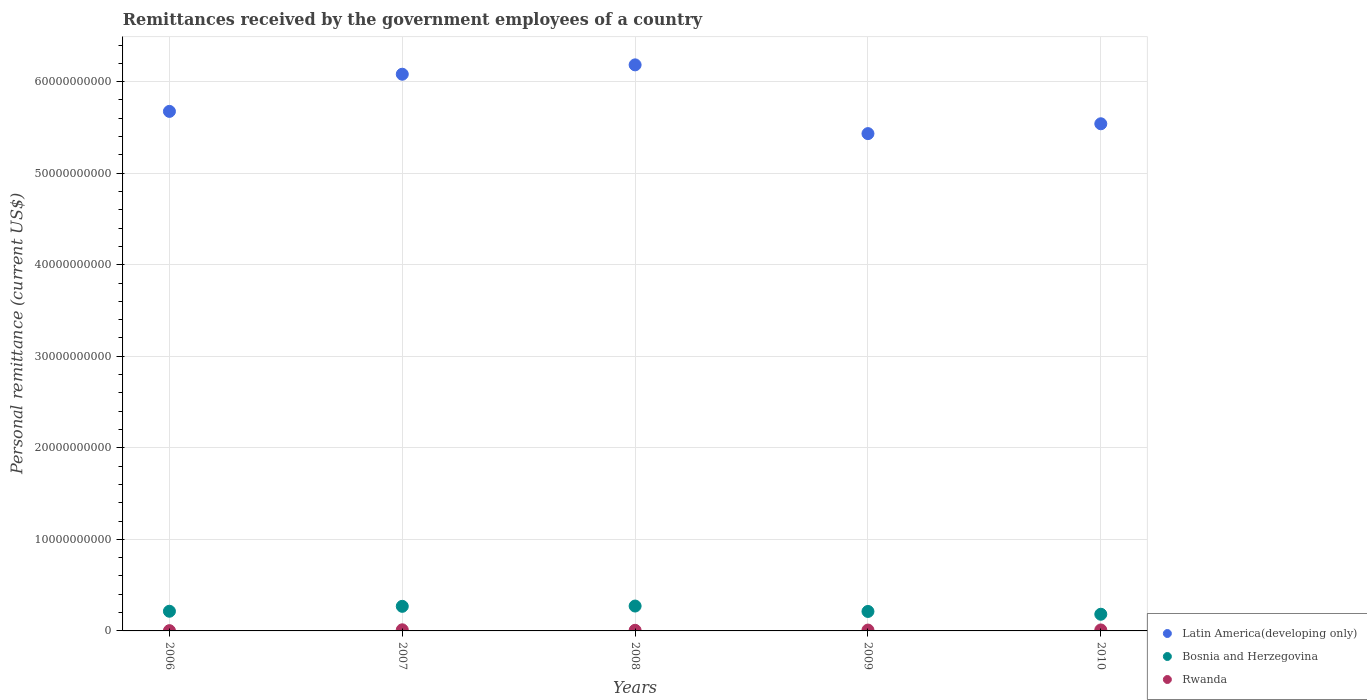How many different coloured dotlines are there?
Provide a succinct answer. 3. Is the number of dotlines equal to the number of legend labels?
Offer a terse response. Yes. What is the remittances received by the government employees in Rwanda in 2006?
Your response must be concise. 2.90e+07. Across all years, what is the maximum remittances received by the government employees in Latin America(developing only)?
Give a very brief answer. 6.18e+1. Across all years, what is the minimum remittances received by the government employees in Latin America(developing only)?
Make the answer very short. 5.43e+1. In which year was the remittances received by the government employees in Bosnia and Herzegovina maximum?
Provide a short and direct response. 2008. In which year was the remittances received by the government employees in Rwanda minimum?
Your answer should be compact. 2006. What is the total remittances received by the government employees in Bosnia and Herzegovina in the graph?
Provide a short and direct response. 1.15e+1. What is the difference between the remittances received by the government employees in Bosnia and Herzegovina in 2006 and that in 2007?
Your response must be concise. -5.37e+08. What is the difference between the remittances received by the government employees in Rwanda in 2006 and the remittances received by the government employees in Bosnia and Herzegovina in 2008?
Your answer should be very brief. -2.69e+09. What is the average remittances received by the government employees in Latin America(developing only) per year?
Make the answer very short. 5.78e+1. In the year 2010, what is the difference between the remittances received by the government employees in Latin America(developing only) and remittances received by the government employees in Bosnia and Herzegovina?
Offer a terse response. 5.36e+1. In how many years, is the remittances received by the government employees in Bosnia and Herzegovina greater than 36000000000 US$?
Your answer should be very brief. 0. What is the ratio of the remittances received by the government employees in Bosnia and Herzegovina in 2008 to that in 2009?
Your answer should be compact. 1.28. Is the difference between the remittances received by the government employees in Latin America(developing only) in 2009 and 2010 greater than the difference between the remittances received by the government employees in Bosnia and Herzegovina in 2009 and 2010?
Provide a succinct answer. No. What is the difference between the highest and the second highest remittances received by the government employees in Rwanda?
Make the answer very short. 1.50e+07. What is the difference between the highest and the lowest remittances received by the government employees in Rwanda?
Ensure brevity in your answer.  9.25e+07. Is the sum of the remittances received by the government employees in Latin America(developing only) in 2006 and 2007 greater than the maximum remittances received by the government employees in Rwanda across all years?
Provide a short and direct response. Yes. Does the remittances received by the government employees in Latin America(developing only) monotonically increase over the years?
Provide a short and direct response. No. Is the remittances received by the government employees in Bosnia and Herzegovina strictly less than the remittances received by the government employees in Rwanda over the years?
Your response must be concise. No. How many dotlines are there?
Provide a short and direct response. 3. What is the difference between two consecutive major ticks on the Y-axis?
Your answer should be compact. 1.00e+1. How are the legend labels stacked?
Offer a terse response. Vertical. What is the title of the graph?
Your answer should be very brief. Remittances received by the government employees of a country. What is the label or title of the X-axis?
Your response must be concise. Years. What is the label or title of the Y-axis?
Ensure brevity in your answer.  Personal remittance (current US$). What is the Personal remittance (current US$) of Latin America(developing only) in 2006?
Offer a very short reply. 5.68e+1. What is the Personal remittance (current US$) in Bosnia and Herzegovina in 2006?
Provide a succinct answer. 2.15e+09. What is the Personal remittance (current US$) in Rwanda in 2006?
Your answer should be compact. 2.90e+07. What is the Personal remittance (current US$) of Latin America(developing only) in 2007?
Your answer should be very brief. 6.08e+1. What is the Personal remittance (current US$) in Bosnia and Herzegovina in 2007?
Ensure brevity in your answer.  2.69e+09. What is the Personal remittance (current US$) of Rwanda in 2007?
Your answer should be very brief. 1.21e+08. What is the Personal remittance (current US$) of Latin America(developing only) in 2008?
Provide a short and direct response. 6.18e+1. What is the Personal remittance (current US$) of Bosnia and Herzegovina in 2008?
Provide a succinct answer. 2.72e+09. What is the Personal remittance (current US$) in Rwanda in 2008?
Provide a short and direct response. 6.78e+07. What is the Personal remittance (current US$) of Latin America(developing only) in 2009?
Keep it short and to the point. 5.43e+1. What is the Personal remittance (current US$) of Bosnia and Herzegovina in 2009?
Ensure brevity in your answer.  2.13e+09. What is the Personal remittance (current US$) of Rwanda in 2009?
Offer a very short reply. 9.26e+07. What is the Personal remittance (current US$) in Latin America(developing only) in 2010?
Your answer should be very brief. 5.54e+1. What is the Personal remittance (current US$) of Bosnia and Herzegovina in 2010?
Provide a short and direct response. 1.82e+09. What is the Personal remittance (current US$) in Rwanda in 2010?
Ensure brevity in your answer.  1.06e+08. Across all years, what is the maximum Personal remittance (current US$) in Latin America(developing only)?
Make the answer very short. 6.18e+1. Across all years, what is the maximum Personal remittance (current US$) in Bosnia and Herzegovina?
Offer a very short reply. 2.72e+09. Across all years, what is the maximum Personal remittance (current US$) in Rwanda?
Keep it short and to the point. 1.21e+08. Across all years, what is the minimum Personal remittance (current US$) in Latin America(developing only)?
Keep it short and to the point. 5.43e+1. Across all years, what is the minimum Personal remittance (current US$) in Bosnia and Herzegovina?
Ensure brevity in your answer.  1.82e+09. Across all years, what is the minimum Personal remittance (current US$) of Rwanda?
Give a very brief answer. 2.90e+07. What is the total Personal remittance (current US$) of Latin America(developing only) in the graph?
Ensure brevity in your answer.  2.89e+11. What is the total Personal remittance (current US$) in Bosnia and Herzegovina in the graph?
Your answer should be compact. 1.15e+1. What is the total Personal remittance (current US$) of Rwanda in the graph?
Provide a short and direct response. 4.17e+08. What is the difference between the Personal remittance (current US$) in Latin America(developing only) in 2006 and that in 2007?
Ensure brevity in your answer.  -4.06e+09. What is the difference between the Personal remittance (current US$) of Bosnia and Herzegovina in 2006 and that in 2007?
Your response must be concise. -5.37e+08. What is the difference between the Personal remittance (current US$) in Rwanda in 2006 and that in 2007?
Provide a succinct answer. -9.25e+07. What is the difference between the Personal remittance (current US$) of Latin America(developing only) in 2006 and that in 2008?
Your answer should be compact. -5.08e+09. What is the difference between the Personal remittance (current US$) in Bosnia and Herzegovina in 2006 and that in 2008?
Ensure brevity in your answer.  -5.69e+08. What is the difference between the Personal remittance (current US$) of Rwanda in 2006 and that in 2008?
Your answer should be compact. -3.88e+07. What is the difference between the Personal remittance (current US$) in Latin America(developing only) in 2006 and that in 2009?
Ensure brevity in your answer.  2.43e+09. What is the difference between the Personal remittance (current US$) in Bosnia and Herzegovina in 2006 and that in 2009?
Offer a terse response. 2.19e+07. What is the difference between the Personal remittance (current US$) of Rwanda in 2006 and that in 2009?
Offer a terse response. -6.36e+07. What is the difference between the Personal remittance (current US$) in Latin America(developing only) in 2006 and that in 2010?
Provide a short and direct response. 1.35e+09. What is the difference between the Personal remittance (current US$) of Bosnia and Herzegovina in 2006 and that in 2010?
Provide a short and direct response. 3.27e+08. What is the difference between the Personal remittance (current US$) in Rwanda in 2006 and that in 2010?
Ensure brevity in your answer.  -7.75e+07. What is the difference between the Personal remittance (current US$) of Latin America(developing only) in 2007 and that in 2008?
Your answer should be compact. -1.02e+09. What is the difference between the Personal remittance (current US$) in Bosnia and Herzegovina in 2007 and that in 2008?
Offer a terse response. -3.12e+07. What is the difference between the Personal remittance (current US$) in Rwanda in 2007 and that in 2008?
Your answer should be very brief. 5.37e+07. What is the difference between the Personal remittance (current US$) in Latin America(developing only) in 2007 and that in 2009?
Keep it short and to the point. 6.49e+09. What is the difference between the Personal remittance (current US$) of Bosnia and Herzegovina in 2007 and that in 2009?
Provide a short and direct response. 5.59e+08. What is the difference between the Personal remittance (current US$) of Rwanda in 2007 and that in 2009?
Offer a terse response. 2.89e+07. What is the difference between the Personal remittance (current US$) in Latin America(developing only) in 2007 and that in 2010?
Keep it short and to the point. 5.41e+09. What is the difference between the Personal remittance (current US$) of Bosnia and Herzegovina in 2007 and that in 2010?
Your answer should be very brief. 8.64e+08. What is the difference between the Personal remittance (current US$) of Rwanda in 2007 and that in 2010?
Offer a terse response. 1.50e+07. What is the difference between the Personal remittance (current US$) of Latin America(developing only) in 2008 and that in 2009?
Keep it short and to the point. 7.51e+09. What is the difference between the Personal remittance (current US$) in Bosnia and Herzegovina in 2008 and that in 2009?
Provide a succinct answer. 5.91e+08. What is the difference between the Personal remittance (current US$) in Rwanda in 2008 and that in 2009?
Your answer should be compact. -2.48e+07. What is the difference between the Personal remittance (current US$) in Latin America(developing only) in 2008 and that in 2010?
Offer a terse response. 6.44e+09. What is the difference between the Personal remittance (current US$) in Bosnia and Herzegovina in 2008 and that in 2010?
Your answer should be compact. 8.95e+08. What is the difference between the Personal remittance (current US$) of Rwanda in 2008 and that in 2010?
Offer a very short reply. -3.87e+07. What is the difference between the Personal remittance (current US$) of Latin America(developing only) in 2009 and that in 2010?
Provide a short and direct response. -1.07e+09. What is the difference between the Personal remittance (current US$) in Bosnia and Herzegovina in 2009 and that in 2010?
Keep it short and to the point. 3.05e+08. What is the difference between the Personal remittance (current US$) in Rwanda in 2009 and that in 2010?
Offer a terse response. -1.38e+07. What is the difference between the Personal remittance (current US$) in Latin America(developing only) in 2006 and the Personal remittance (current US$) in Bosnia and Herzegovina in 2007?
Give a very brief answer. 5.41e+1. What is the difference between the Personal remittance (current US$) in Latin America(developing only) in 2006 and the Personal remittance (current US$) in Rwanda in 2007?
Your answer should be compact. 5.66e+1. What is the difference between the Personal remittance (current US$) of Bosnia and Herzegovina in 2006 and the Personal remittance (current US$) of Rwanda in 2007?
Offer a very short reply. 2.03e+09. What is the difference between the Personal remittance (current US$) of Latin America(developing only) in 2006 and the Personal remittance (current US$) of Bosnia and Herzegovina in 2008?
Your answer should be very brief. 5.40e+1. What is the difference between the Personal remittance (current US$) of Latin America(developing only) in 2006 and the Personal remittance (current US$) of Rwanda in 2008?
Provide a short and direct response. 5.67e+1. What is the difference between the Personal remittance (current US$) in Bosnia and Herzegovina in 2006 and the Personal remittance (current US$) in Rwanda in 2008?
Your answer should be compact. 2.08e+09. What is the difference between the Personal remittance (current US$) of Latin America(developing only) in 2006 and the Personal remittance (current US$) of Bosnia and Herzegovina in 2009?
Your answer should be compact. 5.46e+1. What is the difference between the Personal remittance (current US$) in Latin America(developing only) in 2006 and the Personal remittance (current US$) in Rwanda in 2009?
Make the answer very short. 5.67e+1. What is the difference between the Personal remittance (current US$) of Bosnia and Herzegovina in 2006 and the Personal remittance (current US$) of Rwanda in 2009?
Keep it short and to the point. 2.06e+09. What is the difference between the Personal remittance (current US$) in Latin America(developing only) in 2006 and the Personal remittance (current US$) in Bosnia and Herzegovina in 2010?
Ensure brevity in your answer.  5.49e+1. What is the difference between the Personal remittance (current US$) of Latin America(developing only) in 2006 and the Personal remittance (current US$) of Rwanda in 2010?
Your answer should be very brief. 5.66e+1. What is the difference between the Personal remittance (current US$) of Bosnia and Herzegovina in 2006 and the Personal remittance (current US$) of Rwanda in 2010?
Provide a short and direct response. 2.04e+09. What is the difference between the Personal remittance (current US$) of Latin America(developing only) in 2007 and the Personal remittance (current US$) of Bosnia and Herzegovina in 2008?
Keep it short and to the point. 5.81e+1. What is the difference between the Personal remittance (current US$) in Latin America(developing only) in 2007 and the Personal remittance (current US$) in Rwanda in 2008?
Your answer should be compact. 6.07e+1. What is the difference between the Personal remittance (current US$) of Bosnia and Herzegovina in 2007 and the Personal remittance (current US$) of Rwanda in 2008?
Offer a terse response. 2.62e+09. What is the difference between the Personal remittance (current US$) of Latin America(developing only) in 2007 and the Personal remittance (current US$) of Bosnia and Herzegovina in 2009?
Give a very brief answer. 5.87e+1. What is the difference between the Personal remittance (current US$) in Latin America(developing only) in 2007 and the Personal remittance (current US$) in Rwanda in 2009?
Your answer should be very brief. 6.07e+1. What is the difference between the Personal remittance (current US$) in Bosnia and Herzegovina in 2007 and the Personal remittance (current US$) in Rwanda in 2009?
Give a very brief answer. 2.59e+09. What is the difference between the Personal remittance (current US$) of Latin America(developing only) in 2007 and the Personal remittance (current US$) of Bosnia and Herzegovina in 2010?
Offer a very short reply. 5.90e+1. What is the difference between the Personal remittance (current US$) in Latin America(developing only) in 2007 and the Personal remittance (current US$) in Rwanda in 2010?
Provide a succinct answer. 6.07e+1. What is the difference between the Personal remittance (current US$) of Bosnia and Herzegovina in 2007 and the Personal remittance (current US$) of Rwanda in 2010?
Provide a succinct answer. 2.58e+09. What is the difference between the Personal remittance (current US$) in Latin America(developing only) in 2008 and the Personal remittance (current US$) in Bosnia and Herzegovina in 2009?
Offer a terse response. 5.97e+1. What is the difference between the Personal remittance (current US$) in Latin America(developing only) in 2008 and the Personal remittance (current US$) in Rwanda in 2009?
Offer a terse response. 6.17e+1. What is the difference between the Personal remittance (current US$) of Bosnia and Herzegovina in 2008 and the Personal remittance (current US$) of Rwanda in 2009?
Give a very brief answer. 2.63e+09. What is the difference between the Personal remittance (current US$) in Latin America(developing only) in 2008 and the Personal remittance (current US$) in Bosnia and Herzegovina in 2010?
Offer a terse response. 6.00e+1. What is the difference between the Personal remittance (current US$) in Latin America(developing only) in 2008 and the Personal remittance (current US$) in Rwanda in 2010?
Provide a succinct answer. 6.17e+1. What is the difference between the Personal remittance (current US$) of Bosnia and Herzegovina in 2008 and the Personal remittance (current US$) of Rwanda in 2010?
Provide a short and direct response. 2.61e+09. What is the difference between the Personal remittance (current US$) of Latin America(developing only) in 2009 and the Personal remittance (current US$) of Bosnia and Herzegovina in 2010?
Your answer should be very brief. 5.25e+1. What is the difference between the Personal remittance (current US$) in Latin America(developing only) in 2009 and the Personal remittance (current US$) in Rwanda in 2010?
Your response must be concise. 5.42e+1. What is the difference between the Personal remittance (current US$) in Bosnia and Herzegovina in 2009 and the Personal remittance (current US$) in Rwanda in 2010?
Make the answer very short. 2.02e+09. What is the average Personal remittance (current US$) in Latin America(developing only) per year?
Provide a succinct answer. 5.78e+1. What is the average Personal remittance (current US$) of Bosnia and Herzegovina per year?
Offer a very short reply. 2.30e+09. What is the average Personal remittance (current US$) of Rwanda per year?
Ensure brevity in your answer.  8.35e+07. In the year 2006, what is the difference between the Personal remittance (current US$) of Latin America(developing only) and Personal remittance (current US$) of Bosnia and Herzegovina?
Your response must be concise. 5.46e+1. In the year 2006, what is the difference between the Personal remittance (current US$) of Latin America(developing only) and Personal remittance (current US$) of Rwanda?
Provide a short and direct response. 5.67e+1. In the year 2006, what is the difference between the Personal remittance (current US$) in Bosnia and Herzegovina and Personal remittance (current US$) in Rwanda?
Provide a short and direct response. 2.12e+09. In the year 2007, what is the difference between the Personal remittance (current US$) in Latin America(developing only) and Personal remittance (current US$) in Bosnia and Herzegovina?
Ensure brevity in your answer.  5.81e+1. In the year 2007, what is the difference between the Personal remittance (current US$) of Latin America(developing only) and Personal remittance (current US$) of Rwanda?
Give a very brief answer. 6.07e+1. In the year 2007, what is the difference between the Personal remittance (current US$) of Bosnia and Herzegovina and Personal remittance (current US$) of Rwanda?
Make the answer very short. 2.56e+09. In the year 2008, what is the difference between the Personal remittance (current US$) of Latin America(developing only) and Personal remittance (current US$) of Bosnia and Herzegovina?
Ensure brevity in your answer.  5.91e+1. In the year 2008, what is the difference between the Personal remittance (current US$) in Latin America(developing only) and Personal remittance (current US$) in Rwanda?
Keep it short and to the point. 6.18e+1. In the year 2008, what is the difference between the Personal remittance (current US$) of Bosnia and Herzegovina and Personal remittance (current US$) of Rwanda?
Make the answer very short. 2.65e+09. In the year 2009, what is the difference between the Personal remittance (current US$) of Latin America(developing only) and Personal remittance (current US$) of Bosnia and Herzegovina?
Provide a succinct answer. 5.22e+1. In the year 2009, what is the difference between the Personal remittance (current US$) in Latin America(developing only) and Personal remittance (current US$) in Rwanda?
Give a very brief answer. 5.42e+1. In the year 2009, what is the difference between the Personal remittance (current US$) in Bosnia and Herzegovina and Personal remittance (current US$) in Rwanda?
Give a very brief answer. 2.03e+09. In the year 2010, what is the difference between the Personal remittance (current US$) of Latin America(developing only) and Personal remittance (current US$) of Bosnia and Herzegovina?
Provide a short and direct response. 5.36e+1. In the year 2010, what is the difference between the Personal remittance (current US$) of Latin America(developing only) and Personal remittance (current US$) of Rwanda?
Your response must be concise. 5.53e+1. In the year 2010, what is the difference between the Personal remittance (current US$) of Bosnia and Herzegovina and Personal remittance (current US$) of Rwanda?
Offer a very short reply. 1.72e+09. What is the ratio of the Personal remittance (current US$) of Latin America(developing only) in 2006 to that in 2007?
Provide a short and direct response. 0.93. What is the ratio of the Personal remittance (current US$) in Bosnia and Herzegovina in 2006 to that in 2007?
Your answer should be compact. 0.8. What is the ratio of the Personal remittance (current US$) of Rwanda in 2006 to that in 2007?
Provide a succinct answer. 0.24. What is the ratio of the Personal remittance (current US$) of Latin America(developing only) in 2006 to that in 2008?
Provide a short and direct response. 0.92. What is the ratio of the Personal remittance (current US$) of Bosnia and Herzegovina in 2006 to that in 2008?
Your answer should be very brief. 0.79. What is the ratio of the Personal remittance (current US$) in Rwanda in 2006 to that in 2008?
Make the answer very short. 0.43. What is the ratio of the Personal remittance (current US$) of Latin America(developing only) in 2006 to that in 2009?
Provide a short and direct response. 1.04. What is the ratio of the Personal remittance (current US$) in Bosnia and Herzegovina in 2006 to that in 2009?
Ensure brevity in your answer.  1.01. What is the ratio of the Personal remittance (current US$) of Rwanda in 2006 to that in 2009?
Your answer should be very brief. 0.31. What is the ratio of the Personal remittance (current US$) of Latin America(developing only) in 2006 to that in 2010?
Your response must be concise. 1.02. What is the ratio of the Personal remittance (current US$) in Bosnia and Herzegovina in 2006 to that in 2010?
Ensure brevity in your answer.  1.18. What is the ratio of the Personal remittance (current US$) in Rwanda in 2006 to that in 2010?
Offer a terse response. 0.27. What is the ratio of the Personal remittance (current US$) in Latin America(developing only) in 2007 to that in 2008?
Keep it short and to the point. 0.98. What is the ratio of the Personal remittance (current US$) of Bosnia and Herzegovina in 2007 to that in 2008?
Make the answer very short. 0.99. What is the ratio of the Personal remittance (current US$) of Rwanda in 2007 to that in 2008?
Ensure brevity in your answer.  1.79. What is the ratio of the Personal remittance (current US$) of Latin America(developing only) in 2007 to that in 2009?
Provide a short and direct response. 1.12. What is the ratio of the Personal remittance (current US$) of Bosnia and Herzegovina in 2007 to that in 2009?
Provide a succinct answer. 1.26. What is the ratio of the Personal remittance (current US$) of Rwanda in 2007 to that in 2009?
Ensure brevity in your answer.  1.31. What is the ratio of the Personal remittance (current US$) in Latin America(developing only) in 2007 to that in 2010?
Offer a terse response. 1.1. What is the ratio of the Personal remittance (current US$) of Bosnia and Herzegovina in 2007 to that in 2010?
Your answer should be very brief. 1.47. What is the ratio of the Personal remittance (current US$) in Rwanda in 2007 to that in 2010?
Offer a very short reply. 1.14. What is the ratio of the Personal remittance (current US$) of Latin America(developing only) in 2008 to that in 2009?
Keep it short and to the point. 1.14. What is the ratio of the Personal remittance (current US$) of Bosnia and Herzegovina in 2008 to that in 2009?
Your response must be concise. 1.28. What is the ratio of the Personal remittance (current US$) in Rwanda in 2008 to that in 2009?
Your answer should be very brief. 0.73. What is the ratio of the Personal remittance (current US$) of Latin America(developing only) in 2008 to that in 2010?
Make the answer very short. 1.12. What is the ratio of the Personal remittance (current US$) of Bosnia and Herzegovina in 2008 to that in 2010?
Give a very brief answer. 1.49. What is the ratio of the Personal remittance (current US$) of Rwanda in 2008 to that in 2010?
Your answer should be compact. 0.64. What is the ratio of the Personal remittance (current US$) of Latin America(developing only) in 2009 to that in 2010?
Your response must be concise. 0.98. What is the ratio of the Personal remittance (current US$) of Bosnia and Herzegovina in 2009 to that in 2010?
Provide a succinct answer. 1.17. What is the ratio of the Personal remittance (current US$) of Rwanda in 2009 to that in 2010?
Offer a terse response. 0.87. What is the difference between the highest and the second highest Personal remittance (current US$) of Latin America(developing only)?
Make the answer very short. 1.02e+09. What is the difference between the highest and the second highest Personal remittance (current US$) of Bosnia and Herzegovina?
Your response must be concise. 3.12e+07. What is the difference between the highest and the second highest Personal remittance (current US$) of Rwanda?
Offer a very short reply. 1.50e+07. What is the difference between the highest and the lowest Personal remittance (current US$) of Latin America(developing only)?
Provide a short and direct response. 7.51e+09. What is the difference between the highest and the lowest Personal remittance (current US$) in Bosnia and Herzegovina?
Make the answer very short. 8.95e+08. What is the difference between the highest and the lowest Personal remittance (current US$) of Rwanda?
Provide a short and direct response. 9.25e+07. 